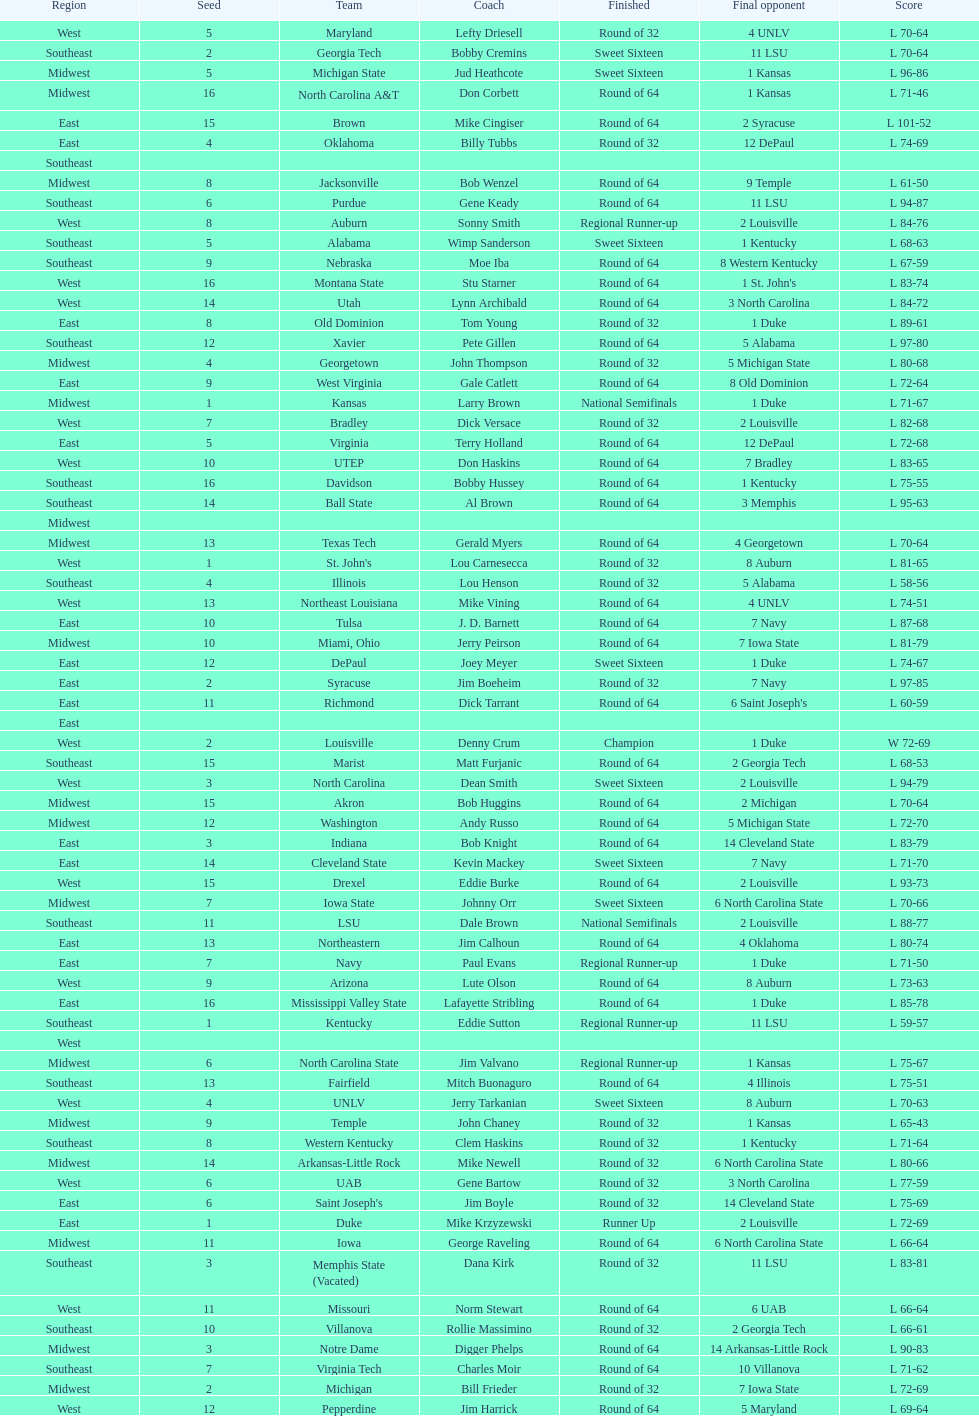Who is the only team from the east region to reach the final round? Duke. 